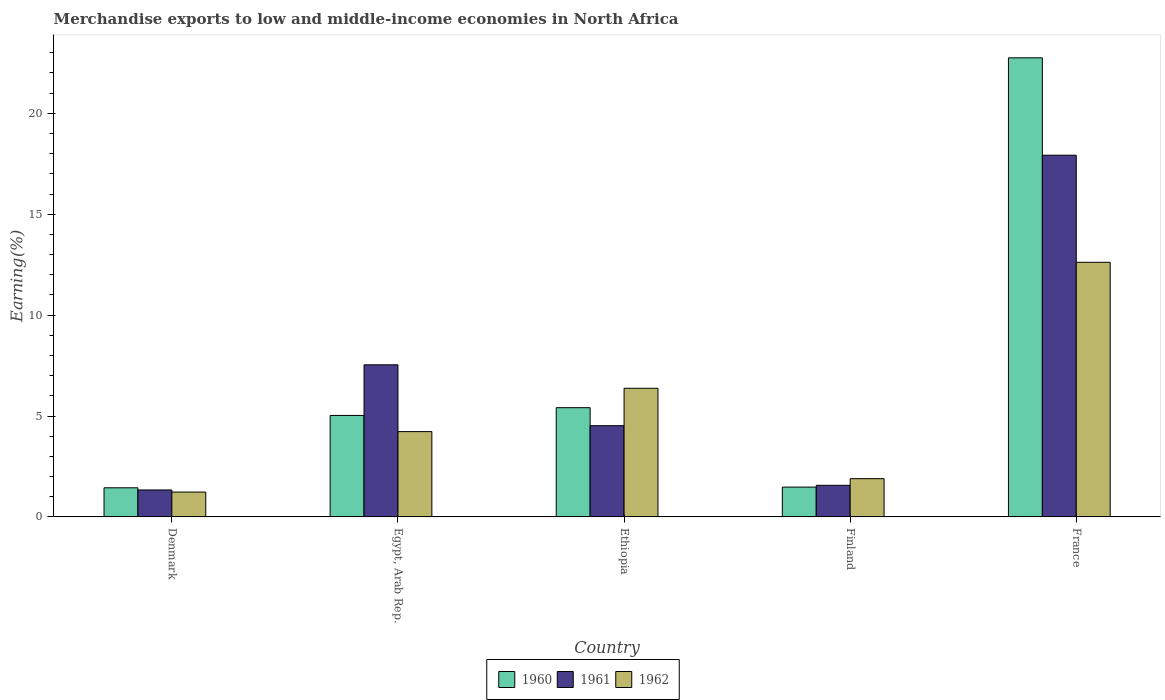How many groups of bars are there?
Ensure brevity in your answer.  5. How many bars are there on the 1st tick from the left?
Offer a terse response. 3. What is the label of the 3rd group of bars from the left?
Your answer should be very brief. Ethiopia. In how many cases, is the number of bars for a given country not equal to the number of legend labels?
Your answer should be very brief. 0. What is the percentage of amount earned from merchandise exports in 1961 in Finland?
Your answer should be compact. 1.57. Across all countries, what is the maximum percentage of amount earned from merchandise exports in 1961?
Make the answer very short. 17.92. Across all countries, what is the minimum percentage of amount earned from merchandise exports in 1960?
Offer a very short reply. 1.44. In which country was the percentage of amount earned from merchandise exports in 1961 maximum?
Ensure brevity in your answer.  France. What is the total percentage of amount earned from merchandise exports in 1960 in the graph?
Give a very brief answer. 36.11. What is the difference between the percentage of amount earned from merchandise exports in 1961 in Finland and that in France?
Offer a terse response. -16.36. What is the difference between the percentage of amount earned from merchandise exports in 1960 in Egypt, Arab Rep. and the percentage of amount earned from merchandise exports in 1961 in Ethiopia?
Your response must be concise. 0.51. What is the average percentage of amount earned from merchandise exports in 1962 per country?
Give a very brief answer. 5.27. What is the difference between the percentage of amount earned from merchandise exports of/in 1961 and percentage of amount earned from merchandise exports of/in 1960 in France?
Give a very brief answer. -4.83. In how many countries, is the percentage of amount earned from merchandise exports in 1962 greater than 9 %?
Offer a very short reply. 1. What is the ratio of the percentage of amount earned from merchandise exports in 1962 in Egypt, Arab Rep. to that in France?
Offer a very short reply. 0.34. Is the percentage of amount earned from merchandise exports in 1962 in Denmark less than that in France?
Offer a terse response. Yes. Is the difference between the percentage of amount earned from merchandise exports in 1961 in Egypt, Arab Rep. and France greater than the difference between the percentage of amount earned from merchandise exports in 1960 in Egypt, Arab Rep. and France?
Your response must be concise. Yes. What is the difference between the highest and the second highest percentage of amount earned from merchandise exports in 1960?
Give a very brief answer. -0.38. What is the difference between the highest and the lowest percentage of amount earned from merchandise exports in 1962?
Ensure brevity in your answer.  11.38. What does the 3rd bar from the left in Ethiopia represents?
Provide a succinct answer. 1962. What does the 3rd bar from the right in Egypt, Arab Rep. represents?
Your response must be concise. 1960. Are all the bars in the graph horizontal?
Provide a short and direct response. No. Does the graph contain any zero values?
Provide a short and direct response. No. Where does the legend appear in the graph?
Provide a short and direct response. Bottom center. What is the title of the graph?
Your answer should be compact. Merchandise exports to low and middle-income economies in North Africa. What is the label or title of the X-axis?
Your answer should be compact. Country. What is the label or title of the Y-axis?
Your response must be concise. Earning(%). What is the Earning(%) in 1960 in Denmark?
Offer a terse response. 1.44. What is the Earning(%) of 1961 in Denmark?
Offer a very short reply. 1.34. What is the Earning(%) in 1962 in Denmark?
Give a very brief answer. 1.23. What is the Earning(%) of 1960 in Egypt, Arab Rep.?
Your answer should be very brief. 5.03. What is the Earning(%) of 1961 in Egypt, Arab Rep.?
Give a very brief answer. 7.54. What is the Earning(%) in 1962 in Egypt, Arab Rep.?
Provide a short and direct response. 4.23. What is the Earning(%) of 1960 in Ethiopia?
Your response must be concise. 5.41. What is the Earning(%) of 1961 in Ethiopia?
Give a very brief answer. 4.52. What is the Earning(%) of 1962 in Ethiopia?
Provide a succinct answer. 6.38. What is the Earning(%) in 1960 in Finland?
Your response must be concise. 1.48. What is the Earning(%) of 1961 in Finland?
Make the answer very short. 1.57. What is the Earning(%) of 1962 in Finland?
Your answer should be compact. 1.9. What is the Earning(%) of 1960 in France?
Give a very brief answer. 22.75. What is the Earning(%) of 1961 in France?
Your answer should be compact. 17.92. What is the Earning(%) in 1962 in France?
Offer a very short reply. 12.62. Across all countries, what is the maximum Earning(%) in 1960?
Offer a terse response. 22.75. Across all countries, what is the maximum Earning(%) in 1961?
Your answer should be compact. 17.92. Across all countries, what is the maximum Earning(%) in 1962?
Provide a succinct answer. 12.62. Across all countries, what is the minimum Earning(%) in 1960?
Your response must be concise. 1.44. Across all countries, what is the minimum Earning(%) of 1961?
Keep it short and to the point. 1.34. Across all countries, what is the minimum Earning(%) in 1962?
Give a very brief answer. 1.23. What is the total Earning(%) in 1960 in the graph?
Give a very brief answer. 36.11. What is the total Earning(%) of 1961 in the graph?
Ensure brevity in your answer.  32.88. What is the total Earning(%) of 1962 in the graph?
Make the answer very short. 26.35. What is the difference between the Earning(%) of 1960 in Denmark and that in Egypt, Arab Rep.?
Your answer should be very brief. -3.58. What is the difference between the Earning(%) of 1961 in Denmark and that in Egypt, Arab Rep.?
Give a very brief answer. -6.2. What is the difference between the Earning(%) in 1962 in Denmark and that in Egypt, Arab Rep.?
Your answer should be very brief. -2.99. What is the difference between the Earning(%) of 1960 in Denmark and that in Ethiopia?
Provide a succinct answer. -3.97. What is the difference between the Earning(%) of 1961 in Denmark and that in Ethiopia?
Make the answer very short. -3.19. What is the difference between the Earning(%) in 1962 in Denmark and that in Ethiopia?
Provide a short and direct response. -5.14. What is the difference between the Earning(%) of 1960 in Denmark and that in Finland?
Your answer should be very brief. -0.03. What is the difference between the Earning(%) in 1961 in Denmark and that in Finland?
Provide a short and direct response. -0.23. What is the difference between the Earning(%) of 1962 in Denmark and that in Finland?
Your answer should be very brief. -0.66. What is the difference between the Earning(%) of 1960 in Denmark and that in France?
Provide a short and direct response. -21.3. What is the difference between the Earning(%) in 1961 in Denmark and that in France?
Give a very brief answer. -16.59. What is the difference between the Earning(%) of 1962 in Denmark and that in France?
Make the answer very short. -11.38. What is the difference between the Earning(%) of 1960 in Egypt, Arab Rep. and that in Ethiopia?
Keep it short and to the point. -0.38. What is the difference between the Earning(%) in 1961 in Egypt, Arab Rep. and that in Ethiopia?
Give a very brief answer. 3.02. What is the difference between the Earning(%) in 1962 in Egypt, Arab Rep. and that in Ethiopia?
Offer a very short reply. -2.15. What is the difference between the Earning(%) in 1960 in Egypt, Arab Rep. and that in Finland?
Ensure brevity in your answer.  3.55. What is the difference between the Earning(%) in 1961 in Egypt, Arab Rep. and that in Finland?
Your answer should be very brief. 5.97. What is the difference between the Earning(%) of 1962 in Egypt, Arab Rep. and that in Finland?
Ensure brevity in your answer.  2.33. What is the difference between the Earning(%) in 1960 in Egypt, Arab Rep. and that in France?
Keep it short and to the point. -17.72. What is the difference between the Earning(%) of 1961 in Egypt, Arab Rep. and that in France?
Offer a very short reply. -10.39. What is the difference between the Earning(%) in 1962 in Egypt, Arab Rep. and that in France?
Your response must be concise. -8.39. What is the difference between the Earning(%) of 1960 in Ethiopia and that in Finland?
Offer a terse response. 3.94. What is the difference between the Earning(%) of 1961 in Ethiopia and that in Finland?
Ensure brevity in your answer.  2.95. What is the difference between the Earning(%) of 1962 in Ethiopia and that in Finland?
Make the answer very short. 4.48. What is the difference between the Earning(%) of 1960 in Ethiopia and that in France?
Make the answer very short. -17.33. What is the difference between the Earning(%) in 1961 in Ethiopia and that in France?
Offer a terse response. -13.4. What is the difference between the Earning(%) in 1962 in Ethiopia and that in France?
Keep it short and to the point. -6.24. What is the difference between the Earning(%) in 1960 in Finland and that in France?
Ensure brevity in your answer.  -21.27. What is the difference between the Earning(%) of 1961 in Finland and that in France?
Your answer should be compact. -16.36. What is the difference between the Earning(%) in 1962 in Finland and that in France?
Give a very brief answer. -10.72. What is the difference between the Earning(%) in 1960 in Denmark and the Earning(%) in 1961 in Egypt, Arab Rep.?
Ensure brevity in your answer.  -6.09. What is the difference between the Earning(%) of 1960 in Denmark and the Earning(%) of 1962 in Egypt, Arab Rep.?
Provide a succinct answer. -2.78. What is the difference between the Earning(%) in 1961 in Denmark and the Earning(%) in 1962 in Egypt, Arab Rep.?
Offer a very short reply. -2.89. What is the difference between the Earning(%) of 1960 in Denmark and the Earning(%) of 1961 in Ethiopia?
Give a very brief answer. -3.08. What is the difference between the Earning(%) in 1960 in Denmark and the Earning(%) in 1962 in Ethiopia?
Your answer should be very brief. -4.93. What is the difference between the Earning(%) in 1961 in Denmark and the Earning(%) in 1962 in Ethiopia?
Provide a succinct answer. -5.04. What is the difference between the Earning(%) in 1960 in Denmark and the Earning(%) in 1961 in Finland?
Your answer should be very brief. -0.12. What is the difference between the Earning(%) in 1960 in Denmark and the Earning(%) in 1962 in Finland?
Offer a very short reply. -0.45. What is the difference between the Earning(%) of 1961 in Denmark and the Earning(%) of 1962 in Finland?
Provide a succinct answer. -0.56. What is the difference between the Earning(%) of 1960 in Denmark and the Earning(%) of 1961 in France?
Ensure brevity in your answer.  -16.48. What is the difference between the Earning(%) in 1960 in Denmark and the Earning(%) in 1962 in France?
Provide a short and direct response. -11.17. What is the difference between the Earning(%) in 1961 in Denmark and the Earning(%) in 1962 in France?
Offer a terse response. -11.28. What is the difference between the Earning(%) in 1960 in Egypt, Arab Rep. and the Earning(%) in 1961 in Ethiopia?
Provide a succinct answer. 0.51. What is the difference between the Earning(%) in 1960 in Egypt, Arab Rep. and the Earning(%) in 1962 in Ethiopia?
Offer a very short reply. -1.35. What is the difference between the Earning(%) of 1961 in Egypt, Arab Rep. and the Earning(%) of 1962 in Ethiopia?
Your answer should be compact. 1.16. What is the difference between the Earning(%) of 1960 in Egypt, Arab Rep. and the Earning(%) of 1961 in Finland?
Your answer should be compact. 3.46. What is the difference between the Earning(%) of 1960 in Egypt, Arab Rep. and the Earning(%) of 1962 in Finland?
Make the answer very short. 3.13. What is the difference between the Earning(%) in 1961 in Egypt, Arab Rep. and the Earning(%) in 1962 in Finland?
Provide a succinct answer. 5.64. What is the difference between the Earning(%) in 1960 in Egypt, Arab Rep. and the Earning(%) in 1961 in France?
Offer a very short reply. -12.89. What is the difference between the Earning(%) in 1960 in Egypt, Arab Rep. and the Earning(%) in 1962 in France?
Make the answer very short. -7.59. What is the difference between the Earning(%) of 1961 in Egypt, Arab Rep. and the Earning(%) of 1962 in France?
Provide a short and direct response. -5.08. What is the difference between the Earning(%) of 1960 in Ethiopia and the Earning(%) of 1961 in Finland?
Your answer should be compact. 3.85. What is the difference between the Earning(%) in 1960 in Ethiopia and the Earning(%) in 1962 in Finland?
Make the answer very short. 3.52. What is the difference between the Earning(%) of 1961 in Ethiopia and the Earning(%) of 1962 in Finland?
Give a very brief answer. 2.63. What is the difference between the Earning(%) in 1960 in Ethiopia and the Earning(%) in 1961 in France?
Make the answer very short. -12.51. What is the difference between the Earning(%) of 1960 in Ethiopia and the Earning(%) of 1962 in France?
Provide a short and direct response. -7.2. What is the difference between the Earning(%) of 1961 in Ethiopia and the Earning(%) of 1962 in France?
Your response must be concise. -8.09. What is the difference between the Earning(%) in 1960 in Finland and the Earning(%) in 1961 in France?
Make the answer very short. -16.44. What is the difference between the Earning(%) in 1960 in Finland and the Earning(%) in 1962 in France?
Your response must be concise. -11.14. What is the difference between the Earning(%) in 1961 in Finland and the Earning(%) in 1962 in France?
Offer a terse response. -11.05. What is the average Earning(%) of 1960 per country?
Ensure brevity in your answer.  7.22. What is the average Earning(%) in 1961 per country?
Ensure brevity in your answer.  6.58. What is the average Earning(%) in 1962 per country?
Make the answer very short. 5.27. What is the difference between the Earning(%) of 1960 and Earning(%) of 1961 in Denmark?
Give a very brief answer. 0.11. What is the difference between the Earning(%) in 1960 and Earning(%) in 1962 in Denmark?
Offer a terse response. 0.21. What is the difference between the Earning(%) of 1961 and Earning(%) of 1962 in Denmark?
Provide a short and direct response. 0.1. What is the difference between the Earning(%) of 1960 and Earning(%) of 1961 in Egypt, Arab Rep.?
Give a very brief answer. -2.51. What is the difference between the Earning(%) of 1960 and Earning(%) of 1962 in Egypt, Arab Rep.?
Give a very brief answer. 0.8. What is the difference between the Earning(%) in 1961 and Earning(%) in 1962 in Egypt, Arab Rep.?
Ensure brevity in your answer.  3.31. What is the difference between the Earning(%) of 1960 and Earning(%) of 1961 in Ethiopia?
Give a very brief answer. 0.89. What is the difference between the Earning(%) of 1960 and Earning(%) of 1962 in Ethiopia?
Make the answer very short. -0.96. What is the difference between the Earning(%) in 1961 and Earning(%) in 1962 in Ethiopia?
Offer a very short reply. -1.85. What is the difference between the Earning(%) of 1960 and Earning(%) of 1961 in Finland?
Offer a very short reply. -0.09. What is the difference between the Earning(%) of 1960 and Earning(%) of 1962 in Finland?
Keep it short and to the point. -0.42. What is the difference between the Earning(%) of 1961 and Earning(%) of 1962 in Finland?
Keep it short and to the point. -0.33. What is the difference between the Earning(%) of 1960 and Earning(%) of 1961 in France?
Make the answer very short. 4.83. What is the difference between the Earning(%) in 1960 and Earning(%) in 1962 in France?
Keep it short and to the point. 10.13. What is the difference between the Earning(%) of 1961 and Earning(%) of 1962 in France?
Make the answer very short. 5.31. What is the ratio of the Earning(%) in 1960 in Denmark to that in Egypt, Arab Rep.?
Ensure brevity in your answer.  0.29. What is the ratio of the Earning(%) in 1961 in Denmark to that in Egypt, Arab Rep.?
Give a very brief answer. 0.18. What is the ratio of the Earning(%) of 1962 in Denmark to that in Egypt, Arab Rep.?
Keep it short and to the point. 0.29. What is the ratio of the Earning(%) in 1960 in Denmark to that in Ethiopia?
Make the answer very short. 0.27. What is the ratio of the Earning(%) of 1961 in Denmark to that in Ethiopia?
Offer a very short reply. 0.3. What is the ratio of the Earning(%) of 1962 in Denmark to that in Ethiopia?
Keep it short and to the point. 0.19. What is the ratio of the Earning(%) in 1960 in Denmark to that in Finland?
Your answer should be very brief. 0.98. What is the ratio of the Earning(%) in 1961 in Denmark to that in Finland?
Give a very brief answer. 0.85. What is the ratio of the Earning(%) in 1962 in Denmark to that in Finland?
Your answer should be very brief. 0.65. What is the ratio of the Earning(%) in 1960 in Denmark to that in France?
Ensure brevity in your answer.  0.06. What is the ratio of the Earning(%) in 1961 in Denmark to that in France?
Offer a very short reply. 0.07. What is the ratio of the Earning(%) in 1962 in Denmark to that in France?
Offer a very short reply. 0.1. What is the ratio of the Earning(%) of 1960 in Egypt, Arab Rep. to that in Ethiopia?
Keep it short and to the point. 0.93. What is the ratio of the Earning(%) in 1961 in Egypt, Arab Rep. to that in Ethiopia?
Make the answer very short. 1.67. What is the ratio of the Earning(%) of 1962 in Egypt, Arab Rep. to that in Ethiopia?
Make the answer very short. 0.66. What is the ratio of the Earning(%) of 1960 in Egypt, Arab Rep. to that in Finland?
Make the answer very short. 3.4. What is the ratio of the Earning(%) in 1961 in Egypt, Arab Rep. to that in Finland?
Ensure brevity in your answer.  4.81. What is the ratio of the Earning(%) of 1962 in Egypt, Arab Rep. to that in Finland?
Your response must be concise. 2.23. What is the ratio of the Earning(%) of 1960 in Egypt, Arab Rep. to that in France?
Make the answer very short. 0.22. What is the ratio of the Earning(%) in 1961 in Egypt, Arab Rep. to that in France?
Your response must be concise. 0.42. What is the ratio of the Earning(%) of 1962 in Egypt, Arab Rep. to that in France?
Provide a succinct answer. 0.34. What is the ratio of the Earning(%) in 1960 in Ethiopia to that in Finland?
Make the answer very short. 3.66. What is the ratio of the Earning(%) in 1961 in Ethiopia to that in Finland?
Ensure brevity in your answer.  2.89. What is the ratio of the Earning(%) in 1962 in Ethiopia to that in Finland?
Offer a terse response. 3.36. What is the ratio of the Earning(%) in 1960 in Ethiopia to that in France?
Offer a very short reply. 0.24. What is the ratio of the Earning(%) in 1961 in Ethiopia to that in France?
Keep it short and to the point. 0.25. What is the ratio of the Earning(%) of 1962 in Ethiopia to that in France?
Your response must be concise. 0.51. What is the ratio of the Earning(%) in 1960 in Finland to that in France?
Ensure brevity in your answer.  0.07. What is the ratio of the Earning(%) in 1961 in Finland to that in France?
Your response must be concise. 0.09. What is the ratio of the Earning(%) in 1962 in Finland to that in France?
Your answer should be compact. 0.15. What is the difference between the highest and the second highest Earning(%) of 1960?
Your answer should be compact. 17.33. What is the difference between the highest and the second highest Earning(%) of 1961?
Provide a short and direct response. 10.39. What is the difference between the highest and the second highest Earning(%) in 1962?
Offer a very short reply. 6.24. What is the difference between the highest and the lowest Earning(%) of 1960?
Provide a succinct answer. 21.3. What is the difference between the highest and the lowest Earning(%) in 1961?
Your answer should be compact. 16.59. What is the difference between the highest and the lowest Earning(%) in 1962?
Your answer should be very brief. 11.38. 